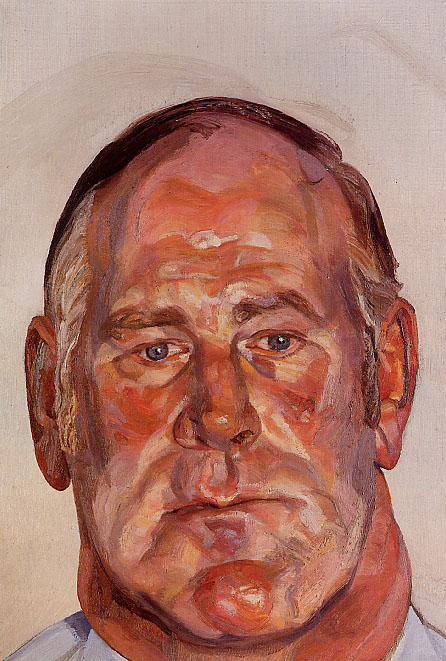What emotions does the artist seem to be trying to convey through the man's expression? The artist appears to portray a deep sense of introspection or quietude through the man's closed eyes and solemn expression. The use of warm, vibrant colors juxtaposed with his serene facial expression could be suggesting inner conflict or a complex emotional state, possibly reflecting moments of reflection or the resolution of inner turmoil. 